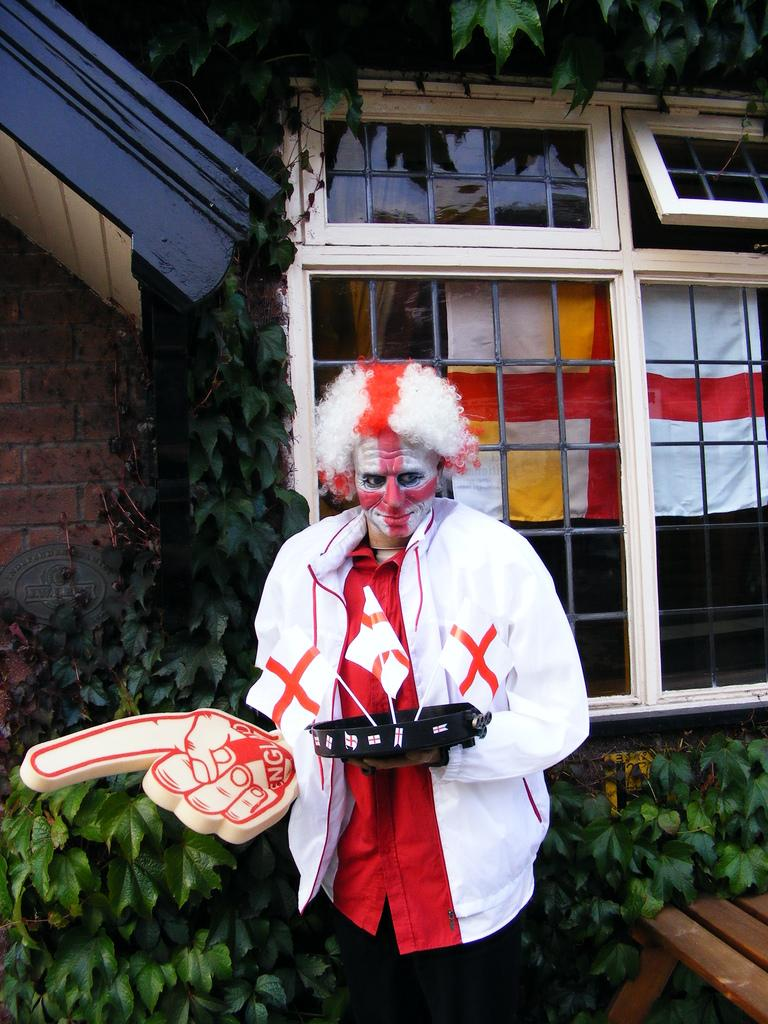Who is present in the image? There is a man in the image. What can be seen in the image besides the man? There are flags and a wooden object in the image. Can you describe the objects in the image? There are objects in the image, including flags and a wooden object. What can be seen in the background of the image? In the background of the image, there are clothes, windows, plants, and a wall. What type of crow is sitting on the judge's shoulder in the image? There is no crow or judge present in the image. 